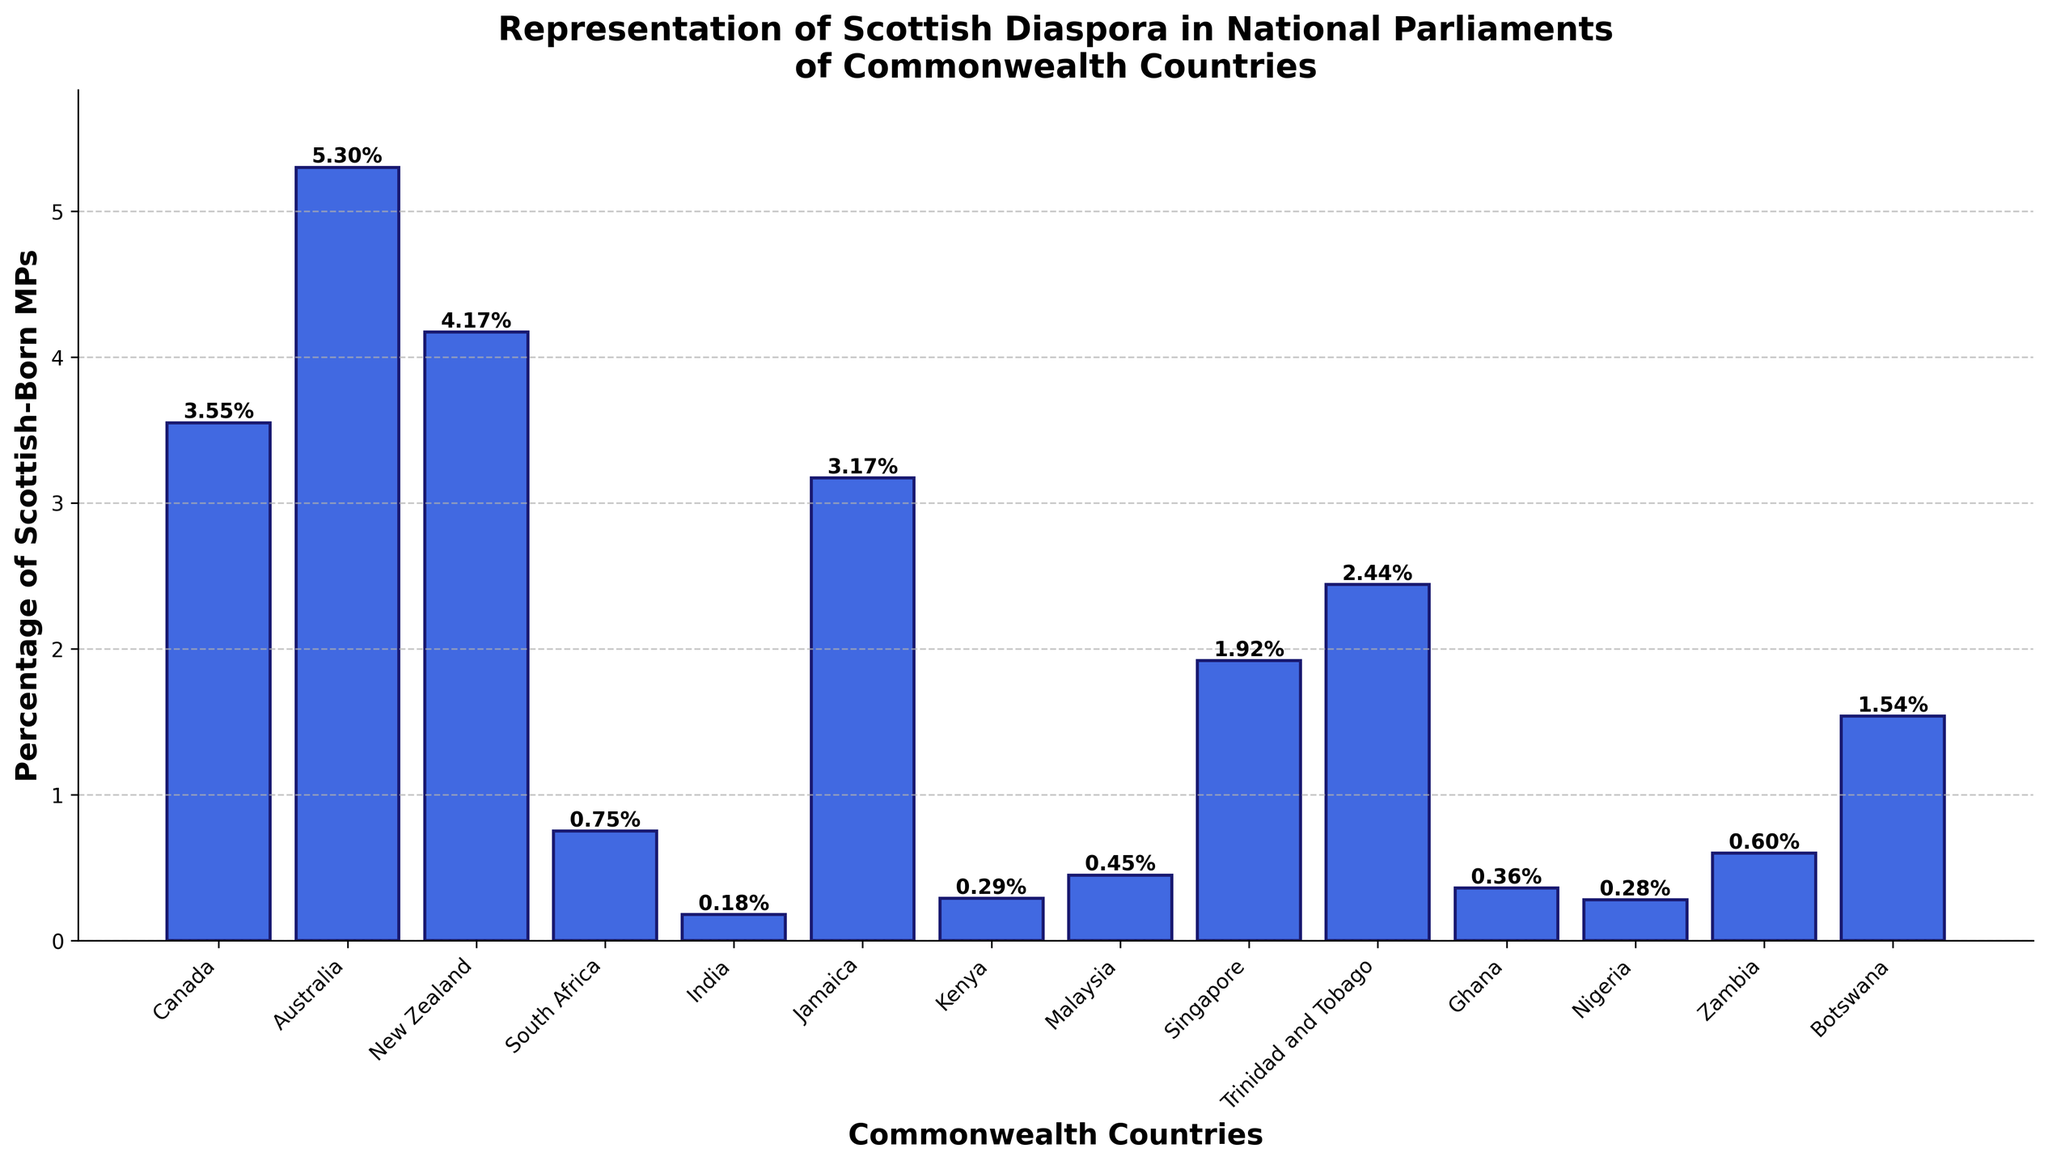Which country has the highest percentage of Scottish-born MPs? The bar with the greatest height represents the country with the highest percentage of Scottish-born MPs. Here, Australia has the tallest bar.
Answer: Australia Which country has a lower percentage of Scottish-born MPs, New Zealand or Singapore? Compare the height of the bars for New Zealand and Singapore. The New Zealand bar is higher than the Singapore bar, indicating a higher percentage in New Zealand.
Answer: Singapore What is the total number of Scottish-born MPs in Canada and Australia combined? Add the Scottish-born MPs from Canada (12) and Australia (8). 12 + 8 = 20
Answer: 20 How many countries have a percentage of Scottish-born MPs higher than 3%? Count the bars that exceed the 3% mark on the y-axis. There are four countries: Canada, Australia, New Zealand, and Jamaica.
Answer: 4 Which country has the lowest representation of Scottish-born MPs in terms of percentage? Identify the country with the shortest bar. India has the shortest bar, with 0.18%.
Answer: India What is the average percentage of Scottish-born MPs across all listed countries? Sum all the percentages and divide by the number of countries (14). The sum is 3.55 + 5.30 + 4.17 + 0.75 + 0.18 + 3.17 + 0.29 + 0.45 + 1.92 + 2.44 + 0.36 + 0.28 + 0.60 + 1.54 = 25.00, so the average is 25.00 / 14 ≈ 1.79%
Answer: 1.79% By how many percentage points does the representation of Scottish-born MPs in South Africa exceed that in Ghana? Subtract the percentage for Ghana (0.36%) from that of South Africa (0.75%). 0.75% - 0.36% = 0.39%
Answer: 0.39% How does the percentage of Scottish-born MPs in Trinidad and Tobago compare to that in Malaysia? Trinidad and Tobago has a bar with a height of 2.44%, while Malaysia has a bar with a height of 0.45%. Therefore, Trinidad and Tobago has a higher percentage.
Answer: Higher Which three countries have the closest percentage of Scottish-born MPs? Find the three percentages that are closest in value. Kenya (0.29%), Nigeria (0.28%), and Ghana (0.36%) are the closest, with differences of 0.01% and 0.07%.
Answer: Kenya, Nigeria, Ghana What is the combined percentage of Scottish-born MPs in countries with less than 1% representation? Add the percentages for countries with less than 1% representation: South Africa (0.75%), India (0.18%), Kenya (0.29%), Malaysia (0.45%), Ghana (0.36%), Nigeria (0.28%), and Zambia (0.60%). 0.75 + 0.18 + 0.29 + 0.45 + 0.36 + 0.28 + 0.60 = 2.91%
Answer: 2.91% 